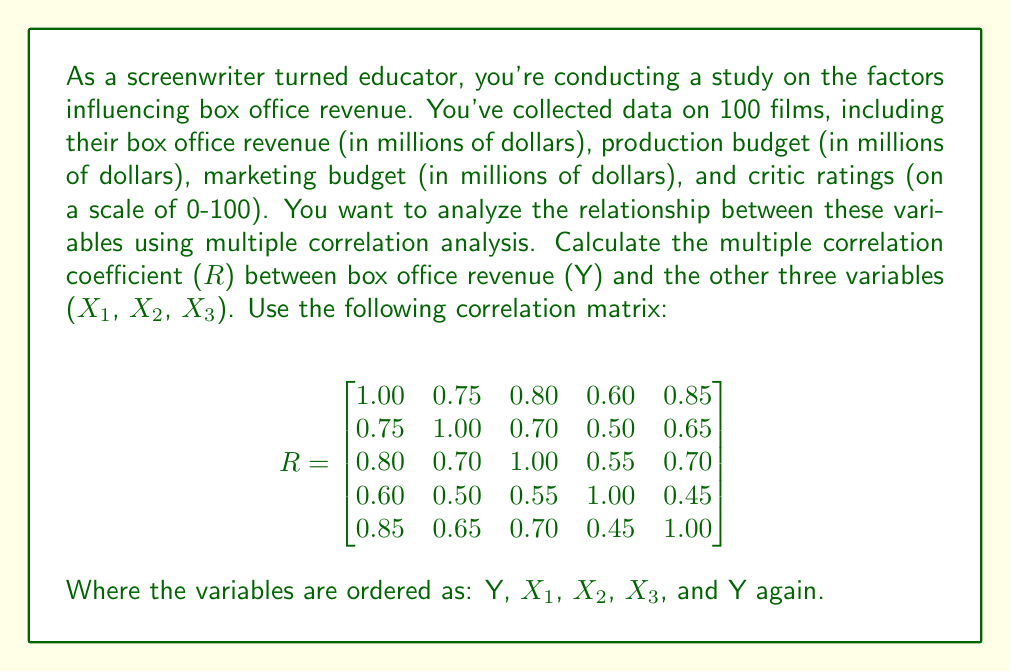Solve this math problem. To calculate the multiple correlation coefficient ($R$) between box office revenue (Y) and the three predictor variables (X₁, X₂, X₃), we'll use the formula:

$$ R = \sqrt{1 - \frac{|R_{XX}|}{|R|}} $$

Where $|R_{XX}|$ is the determinant of the correlation matrix of the predictor variables, and $|R|$ is the determinant of the full correlation matrix.

Step 1: Extract $R_{XX}$ (the correlation matrix of predictor variables)
$$ R_{XX} = \begin{bmatrix}
1.00 & 0.70 & 0.50 \\
0.70 & 1.00 & 0.55 \\
0.50 & 0.55 & 1.00
\end{bmatrix} $$

Step 2: Calculate $|R_{XX}|$
$|R_{XX}| = 1.00(1.00 - 0.55^2) - 0.70(0.70 - 0.50 \times 0.55) + 0.50(0.70 \times 0.55 - 0.50)$
$|R_{XX}| = 1.00(0.6975) - 0.70(0.425) + 0.50(0.085)$
$|R_{XX}| = 0.6975 - 0.2975 + 0.0425 = 0.4425$

Step 3: Calculate $|R|$ (the determinant of the full correlation matrix)
We can use the cofactor expansion along the first row:
$|R| = 1.00(0.4425) - 0.75(-0.0575) + 0.80(0.0375) - 0.60(-0.0725) + 0.85(-0.0325)$
$|R| = 0.4425 + 0.043125 + 0.03 + 0.0435 - 0.027625 = 0.53150$

Step 4: Calculate $R$
$$ R = \sqrt{1 - \frac{|R_{XX}|}{|R|}} = \sqrt{1 - \frac{0.4425}{0.53150}} $$
$$ R = \sqrt{1 - 0.8325} = \sqrt{0.1675} = 0.4093 $$

Therefore, the multiple correlation coefficient between box office revenue and the three predictor variables is approximately 0.4093.
Answer: $R = 0.4093$ 